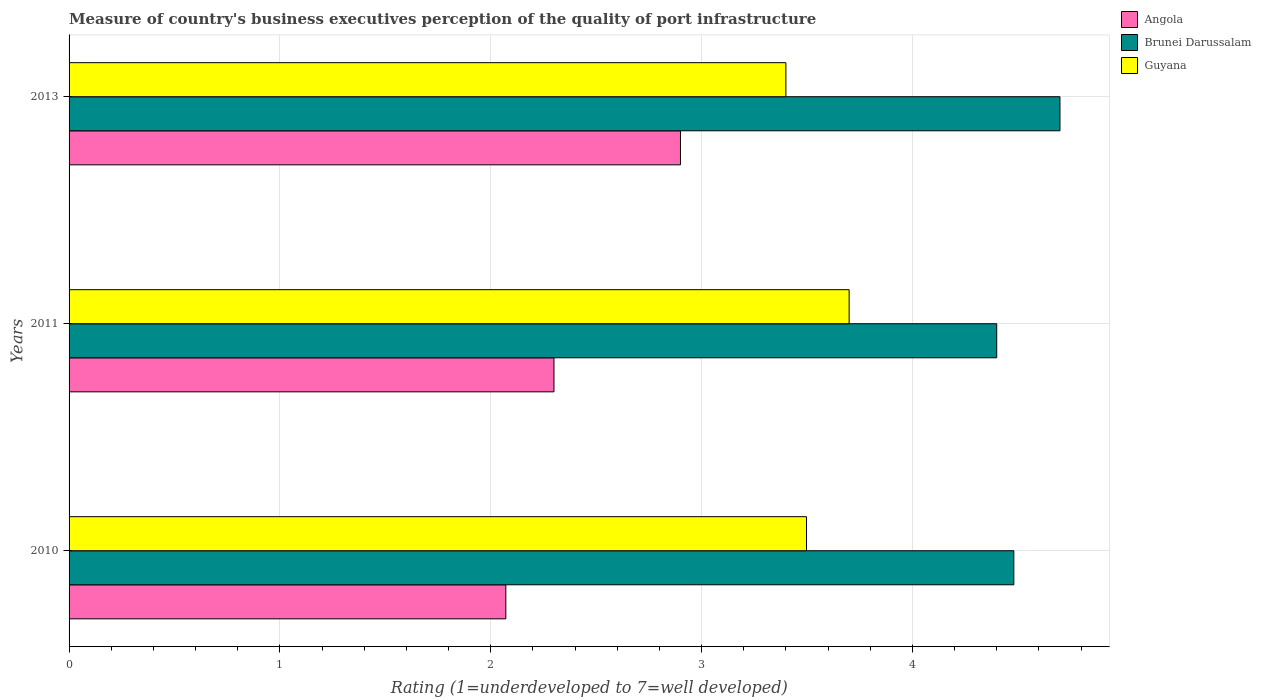How many different coloured bars are there?
Give a very brief answer. 3. Are the number of bars on each tick of the Y-axis equal?
Ensure brevity in your answer.  Yes. How many bars are there on the 3rd tick from the bottom?
Provide a succinct answer. 3. What is the label of the 3rd group of bars from the top?
Offer a terse response. 2010. What is the ratings of the quality of port infrastructure in Brunei Darussalam in 2010?
Keep it short and to the point. 4.48. Across all years, what is the minimum ratings of the quality of port infrastructure in Angola?
Your response must be concise. 2.07. What is the total ratings of the quality of port infrastructure in Guyana in the graph?
Offer a very short reply. 10.6. What is the difference between the ratings of the quality of port infrastructure in Angola in 2010 and that in 2013?
Make the answer very short. -0.83. What is the difference between the ratings of the quality of port infrastructure in Brunei Darussalam in 2011 and the ratings of the quality of port infrastructure in Angola in 2013?
Give a very brief answer. 1.5. What is the average ratings of the quality of port infrastructure in Guyana per year?
Keep it short and to the point. 3.53. In the year 2010, what is the difference between the ratings of the quality of port infrastructure in Angola and ratings of the quality of port infrastructure in Brunei Darussalam?
Provide a succinct answer. -2.41. What is the ratio of the ratings of the quality of port infrastructure in Angola in 2010 to that in 2011?
Offer a very short reply. 0.9. What is the difference between the highest and the second highest ratings of the quality of port infrastructure in Angola?
Ensure brevity in your answer.  0.6. What is the difference between the highest and the lowest ratings of the quality of port infrastructure in Brunei Darussalam?
Provide a short and direct response. 0.3. In how many years, is the ratings of the quality of port infrastructure in Guyana greater than the average ratings of the quality of port infrastructure in Guyana taken over all years?
Give a very brief answer. 1. What does the 2nd bar from the top in 2010 represents?
Provide a succinct answer. Brunei Darussalam. What does the 1st bar from the bottom in 2010 represents?
Your response must be concise. Angola. How many bars are there?
Your response must be concise. 9. How many years are there in the graph?
Your answer should be very brief. 3. Are the values on the major ticks of X-axis written in scientific E-notation?
Your response must be concise. No. Where does the legend appear in the graph?
Your answer should be compact. Top right. What is the title of the graph?
Give a very brief answer. Measure of country's business executives perception of the quality of port infrastructure. Does "Kosovo" appear as one of the legend labels in the graph?
Your answer should be compact. No. What is the label or title of the X-axis?
Offer a terse response. Rating (1=underdeveloped to 7=well developed). What is the Rating (1=underdeveloped to 7=well developed) in Angola in 2010?
Offer a terse response. 2.07. What is the Rating (1=underdeveloped to 7=well developed) of Brunei Darussalam in 2010?
Offer a very short reply. 4.48. What is the Rating (1=underdeveloped to 7=well developed) of Guyana in 2010?
Keep it short and to the point. 3.5. What is the Rating (1=underdeveloped to 7=well developed) of Angola in 2011?
Provide a succinct answer. 2.3. What is the Rating (1=underdeveloped to 7=well developed) of Brunei Darussalam in 2011?
Give a very brief answer. 4.4. What is the Rating (1=underdeveloped to 7=well developed) of Brunei Darussalam in 2013?
Ensure brevity in your answer.  4.7. What is the Rating (1=underdeveloped to 7=well developed) of Guyana in 2013?
Your answer should be compact. 3.4. Across all years, what is the maximum Rating (1=underdeveloped to 7=well developed) in Angola?
Provide a succinct answer. 2.9. Across all years, what is the minimum Rating (1=underdeveloped to 7=well developed) in Angola?
Provide a succinct answer. 2.07. Across all years, what is the minimum Rating (1=underdeveloped to 7=well developed) in Guyana?
Your answer should be very brief. 3.4. What is the total Rating (1=underdeveloped to 7=well developed) of Angola in the graph?
Ensure brevity in your answer.  7.27. What is the total Rating (1=underdeveloped to 7=well developed) of Brunei Darussalam in the graph?
Your answer should be very brief. 13.58. What is the total Rating (1=underdeveloped to 7=well developed) in Guyana in the graph?
Your answer should be very brief. 10.6. What is the difference between the Rating (1=underdeveloped to 7=well developed) in Angola in 2010 and that in 2011?
Your response must be concise. -0.23. What is the difference between the Rating (1=underdeveloped to 7=well developed) in Brunei Darussalam in 2010 and that in 2011?
Your answer should be very brief. 0.08. What is the difference between the Rating (1=underdeveloped to 7=well developed) of Guyana in 2010 and that in 2011?
Give a very brief answer. -0.2. What is the difference between the Rating (1=underdeveloped to 7=well developed) in Angola in 2010 and that in 2013?
Make the answer very short. -0.83. What is the difference between the Rating (1=underdeveloped to 7=well developed) of Brunei Darussalam in 2010 and that in 2013?
Give a very brief answer. -0.22. What is the difference between the Rating (1=underdeveloped to 7=well developed) in Guyana in 2010 and that in 2013?
Offer a terse response. 0.1. What is the difference between the Rating (1=underdeveloped to 7=well developed) in Angola in 2010 and the Rating (1=underdeveloped to 7=well developed) in Brunei Darussalam in 2011?
Offer a terse response. -2.33. What is the difference between the Rating (1=underdeveloped to 7=well developed) of Angola in 2010 and the Rating (1=underdeveloped to 7=well developed) of Guyana in 2011?
Your answer should be compact. -1.63. What is the difference between the Rating (1=underdeveloped to 7=well developed) in Brunei Darussalam in 2010 and the Rating (1=underdeveloped to 7=well developed) in Guyana in 2011?
Your answer should be very brief. 0.78. What is the difference between the Rating (1=underdeveloped to 7=well developed) of Angola in 2010 and the Rating (1=underdeveloped to 7=well developed) of Brunei Darussalam in 2013?
Keep it short and to the point. -2.63. What is the difference between the Rating (1=underdeveloped to 7=well developed) of Angola in 2010 and the Rating (1=underdeveloped to 7=well developed) of Guyana in 2013?
Provide a succinct answer. -1.33. What is the difference between the Rating (1=underdeveloped to 7=well developed) of Brunei Darussalam in 2010 and the Rating (1=underdeveloped to 7=well developed) of Guyana in 2013?
Your answer should be compact. 1.08. What is the difference between the Rating (1=underdeveloped to 7=well developed) of Brunei Darussalam in 2011 and the Rating (1=underdeveloped to 7=well developed) of Guyana in 2013?
Provide a succinct answer. 1. What is the average Rating (1=underdeveloped to 7=well developed) in Angola per year?
Give a very brief answer. 2.42. What is the average Rating (1=underdeveloped to 7=well developed) of Brunei Darussalam per year?
Provide a short and direct response. 4.53. What is the average Rating (1=underdeveloped to 7=well developed) of Guyana per year?
Keep it short and to the point. 3.53. In the year 2010, what is the difference between the Rating (1=underdeveloped to 7=well developed) of Angola and Rating (1=underdeveloped to 7=well developed) of Brunei Darussalam?
Provide a succinct answer. -2.41. In the year 2010, what is the difference between the Rating (1=underdeveloped to 7=well developed) of Angola and Rating (1=underdeveloped to 7=well developed) of Guyana?
Give a very brief answer. -1.43. In the year 2010, what is the difference between the Rating (1=underdeveloped to 7=well developed) in Brunei Darussalam and Rating (1=underdeveloped to 7=well developed) in Guyana?
Offer a very short reply. 0.98. In the year 2011, what is the difference between the Rating (1=underdeveloped to 7=well developed) of Brunei Darussalam and Rating (1=underdeveloped to 7=well developed) of Guyana?
Offer a very short reply. 0.7. In the year 2013, what is the difference between the Rating (1=underdeveloped to 7=well developed) in Angola and Rating (1=underdeveloped to 7=well developed) in Guyana?
Keep it short and to the point. -0.5. In the year 2013, what is the difference between the Rating (1=underdeveloped to 7=well developed) of Brunei Darussalam and Rating (1=underdeveloped to 7=well developed) of Guyana?
Your response must be concise. 1.3. What is the ratio of the Rating (1=underdeveloped to 7=well developed) of Angola in 2010 to that in 2011?
Provide a succinct answer. 0.9. What is the ratio of the Rating (1=underdeveloped to 7=well developed) in Brunei Darussalam in 2010 to that in 2011?
Your answer should be compact. 1.02. What is the ratio of the Rating (1=underdeveloped to 7=well developed) of Guyana in 2010 to that in 2011?
Give a very brief answer. 0.95. What is the ratio of the Rating (1=underdeveloped to 7=well developed) of Angola in 2010 to that in 2013?
Ensure brevity in your answer.  0.71. What is the ratio of the Rating (1=underdeveloped to 7=well developed) in Brunei Darussalam in 2010 to that in 2013?
Ensure brevity in your answer.  0.95. What is the ratio of the Rating (1=underdeveloped to 7=well developed) of Guyana in 2010 to that in 2013?
Provide a short and direct response. 1.03. What is the ratio of the Rating (1=underdeveloped to 7=well developed) in Angola in 2011 to that in 2013?
Ensure brevity in your answer.  0.79. What is the ratio of the Rating (1=underdeveloped to 7=well developed) of Brunei Darussalam in 2011 to that in 2013?
Your answer should be compact. 0.94. What is the ratio of the Rating (1=underdeveloped to 7=well developed) of Guyana in 2011 to that in 2013?
Offer a terse response. 1.09. What is the difference between the highest and the second highest Rating (1=underdeveloped to 7=well developed) of Brunei Darussalam?
Provide a succinct answer. 0.22. What is the difference between the highest and the second highest Rating (1=underdeveloped to 7=well developed) of Guyana?
Make the answer very short. 0.2. What is the difference between the highest and the lowest Rating (1=underdeveloped to 7=well developed) of Angola?
Ensure brevity in your answer.  0.83. What is the difference between the highest and the lowest Rating (1=underdeveloped to 7=well developed) of Guyana?
Provide a succinct answer. 0.3. 